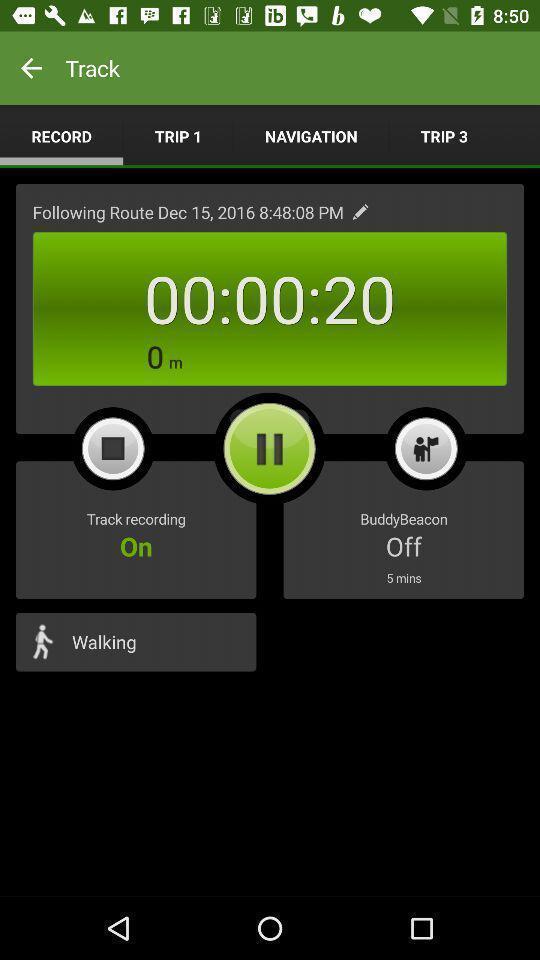Tell me what you see in this picture. Page displaying with recording option in fitness application. 